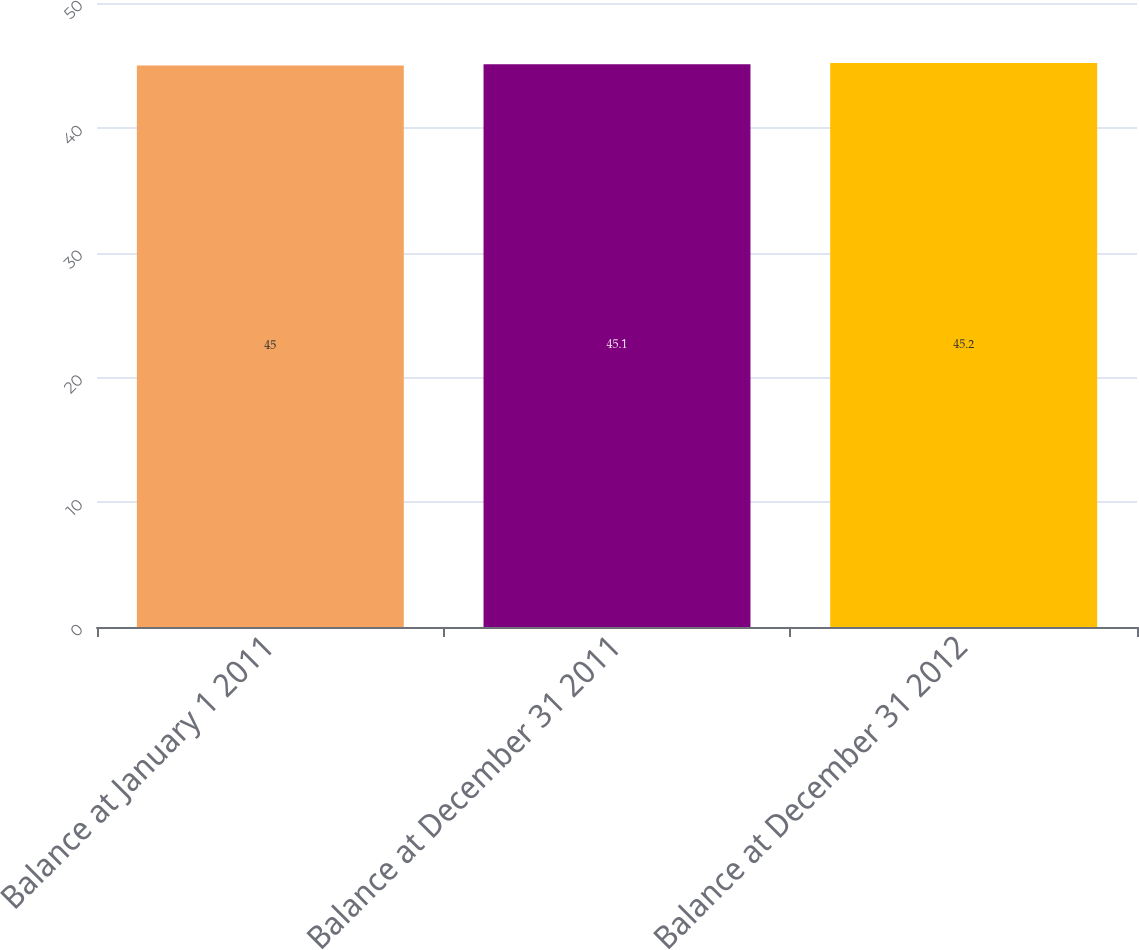<chart> <loc_0><loc_0><loc_500><loc_500><bar_chart><fcel>Balance at January 1 2011<fcel>Balance at December 31 2011<fcel>Balance at December 31 2012<nl><fcel>45<fcel>45.1<fcel>45.2<nl></chart> 